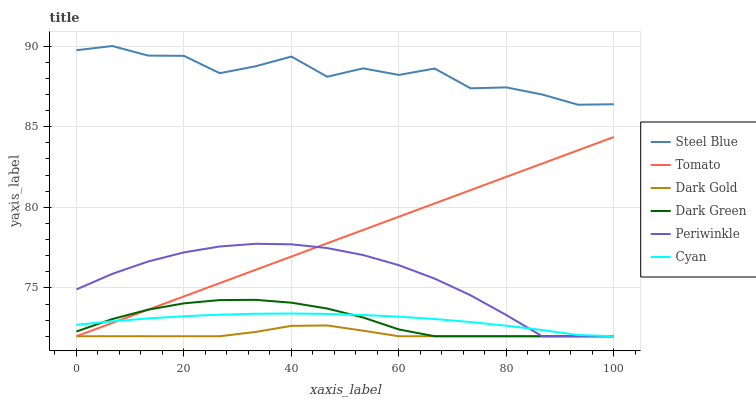Does Dark Gold have the minimum area under the curve?
Answer yes or no. Yes. Does Steel Blue have the maximum area under the curve?
Answer yes or no. Yes. Does Steel Blue have the minimum area under the curve?
Answer yes or no. No. Does Dark Gold have the maximum area under the curve?
Answer yes or no. No. Is Tomato the smoothest?
Answer yes or no. Yes. Is Steel Blue the roughest?
Answer yes or no. Yes. Is Dark Gold the smoothest?
Answer yes or no. No. Is Dark Gold the roughest?
Answer yes or no. No. Does Tomato have the lowest value?
Answer yes or no. Yes. Does Steel Blue have the lowest value?
Answer yes or no. No. Does Steel Blue have the highest value?
Answer yes or no. Yes. Does Dark Gold have the highest value?
Answer yes or no. No. Is Dark Gold less than Steel Blue?
Answer yes or no. Yes. Is Steel Blue greater than Dark Gold?
Answer yes or no. Yes. Does Cyan intersect Dark Green?
Answer yes or no. Yes. Is Cyan less than Dark Green?
Answer yes or no. No. Is Cyan greater than Dark Green?
Answer yes or no. No. Does Dark Gold intersect Steel Blue?
Answer yes or no. No. 